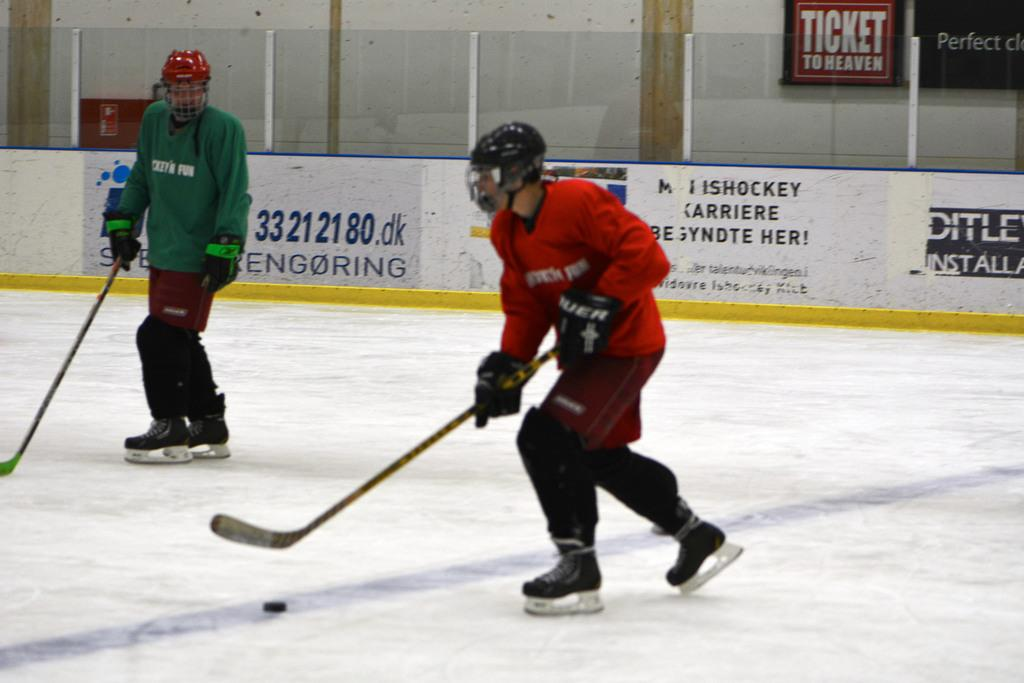Provide a one-sentence caption for the provided image. Ticket to heaven is advertised at the ice hockey rink. 